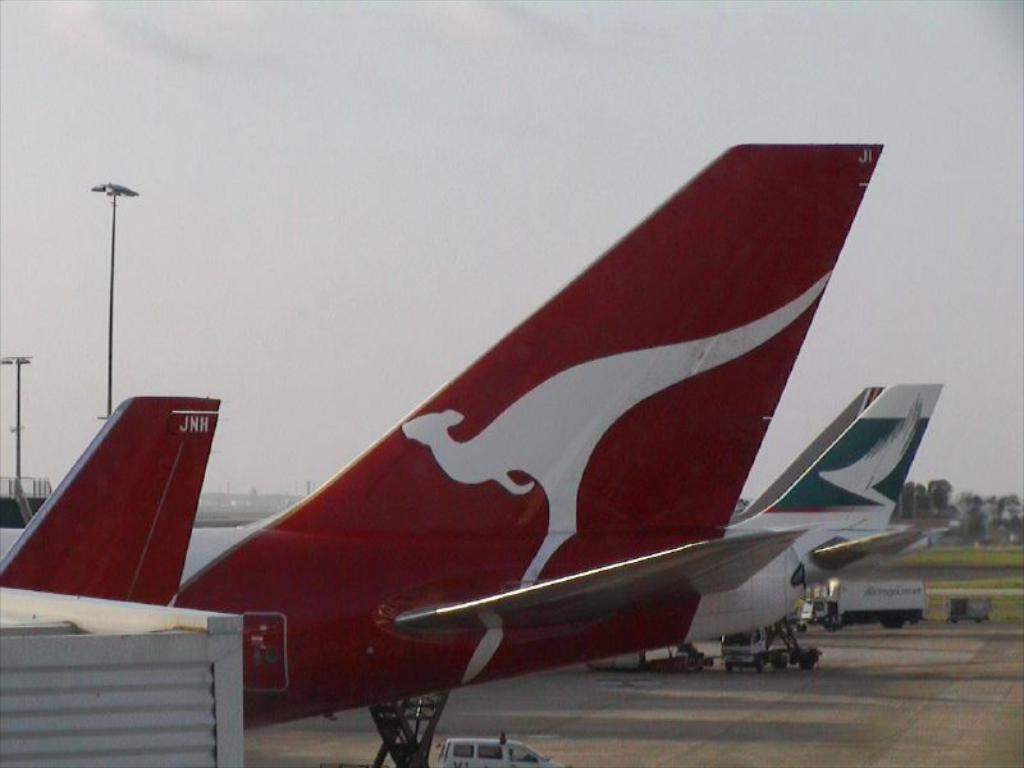What is the main subject of the image? The main subject of the image is airplanes. What else can be seen on the ground in the image? There are vehicles on the ground in the image. What structures are present in the image? There are poles in the image. What type of vegetation is visible in the image? There are trees and grass in the image. What is visible in the background of the image? The sky is visible in the background of the image. How many cherries are hanging from the poles in the image? There are no cherries present in the image; it features airplanes, vehicles, poles, trees, grass, and the sky. What type of slope can be seen in the image? There is no slope present in the image; it features a flat landscape with airplanes, vehicles, poles, trees, grass, and the sky. 